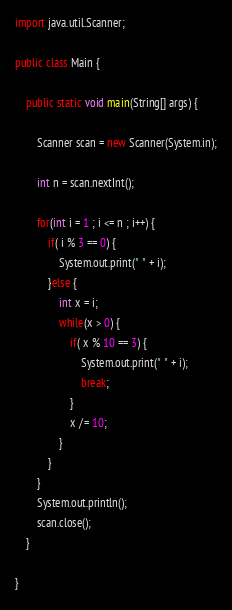<code> <loc_0><loc_0><loc_500><loc_500><_Java_>import java.util.Scanner;

public class Main {

	public static void main(String[] args) {

		Scanner scan = new Scanner(System.in);

		int n = scan.nextInt();

		for(int i = 1 ; i <= n ; i++) {
			if( i % 3 == 0) {
				System.out.print(" " + i);
			}else {
				int x = i;
				while(x > 0) {
					if( x % 10 == 3) {
						System.out.print(" " + i);
						break;
					}
					x /= 10;
				}
			}
		}
		System.out.println();
		scan.close();
	}

}

</code> 